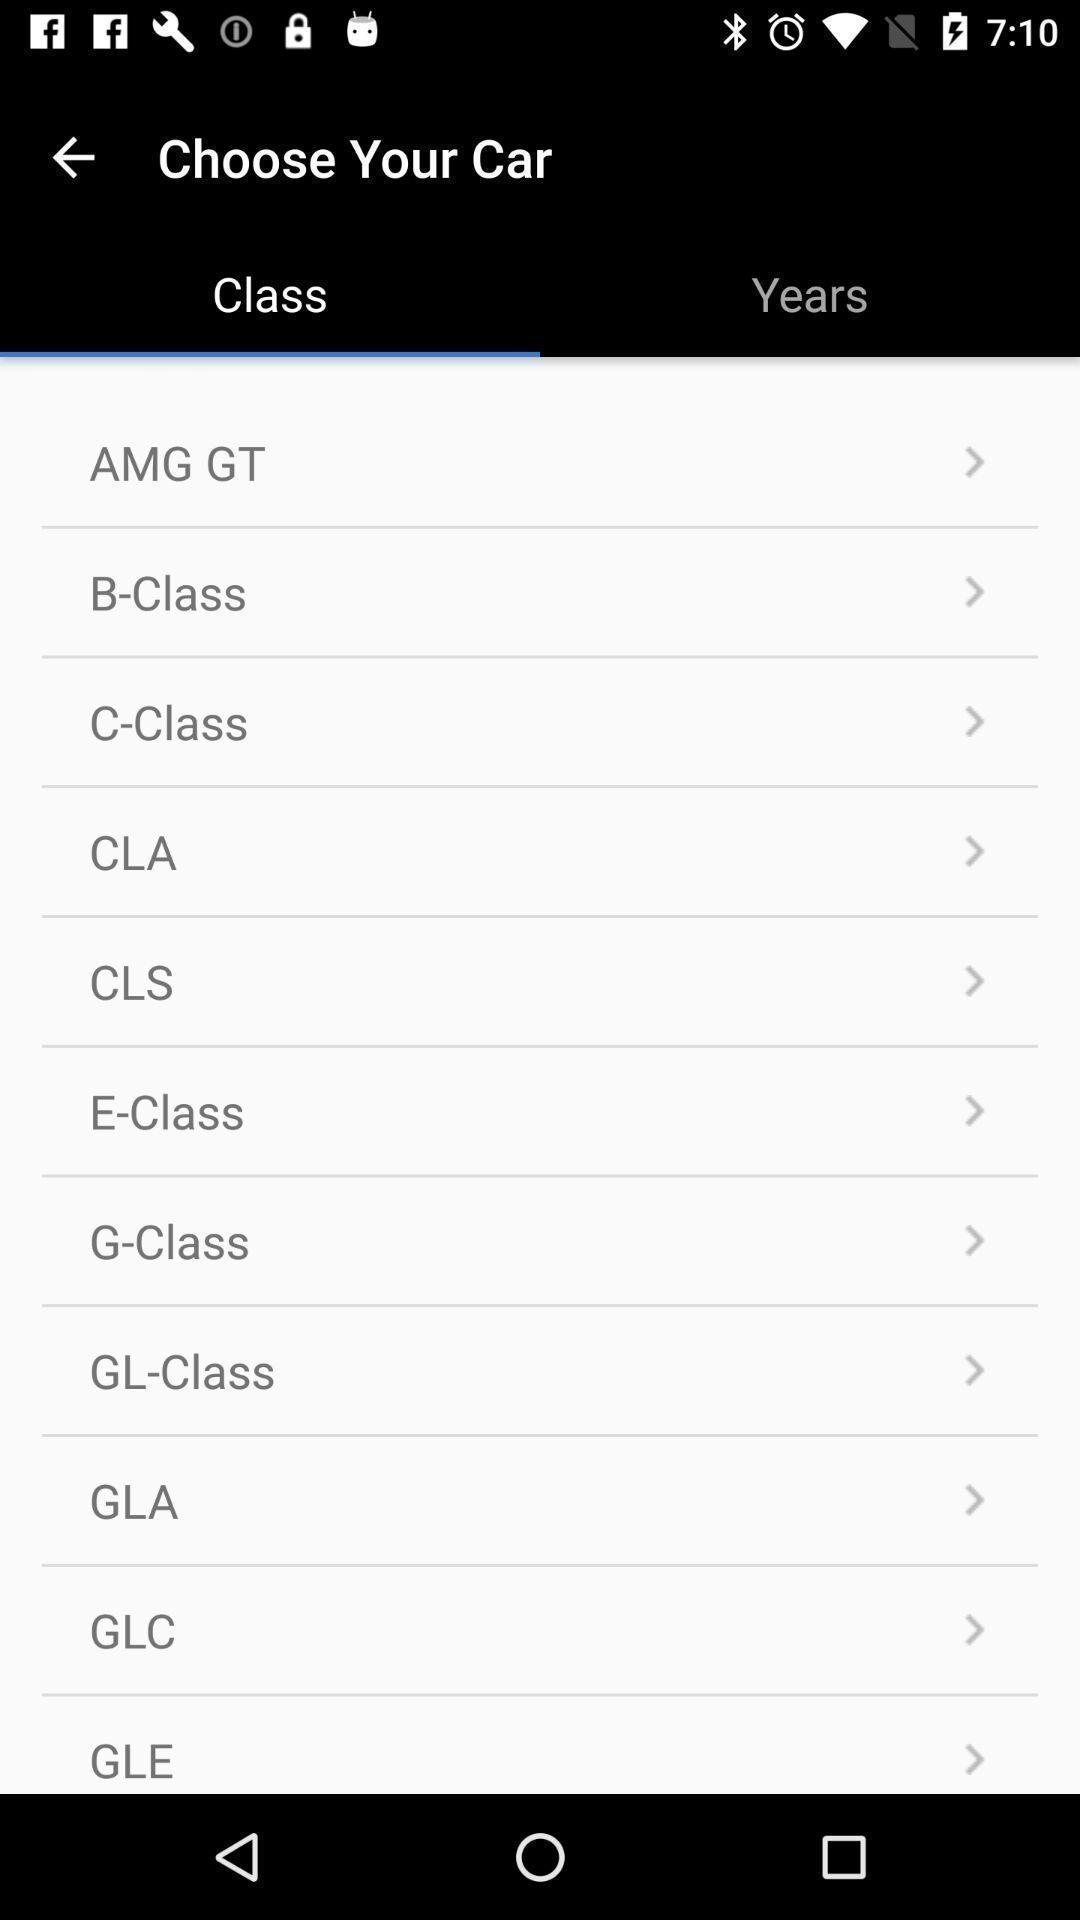What details can you identify in this image? Screen displaying a list of car names. 